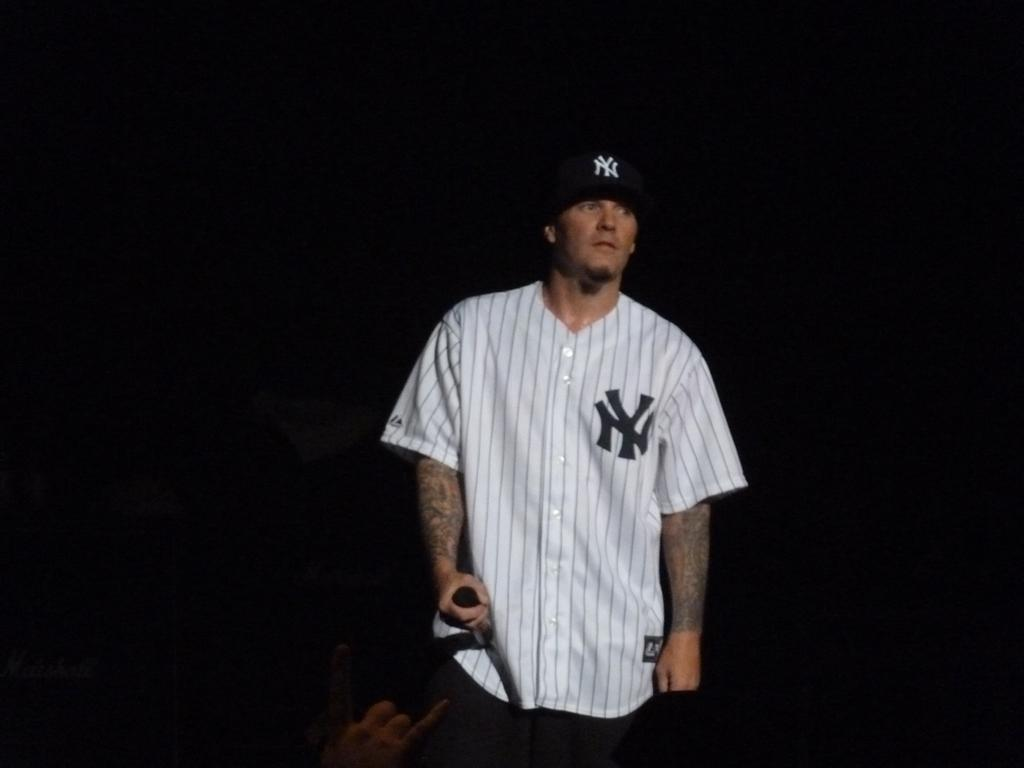<image>
Share a concise interpretation of the image provided. A man is standing wearing a Yankees cap and shirt. 